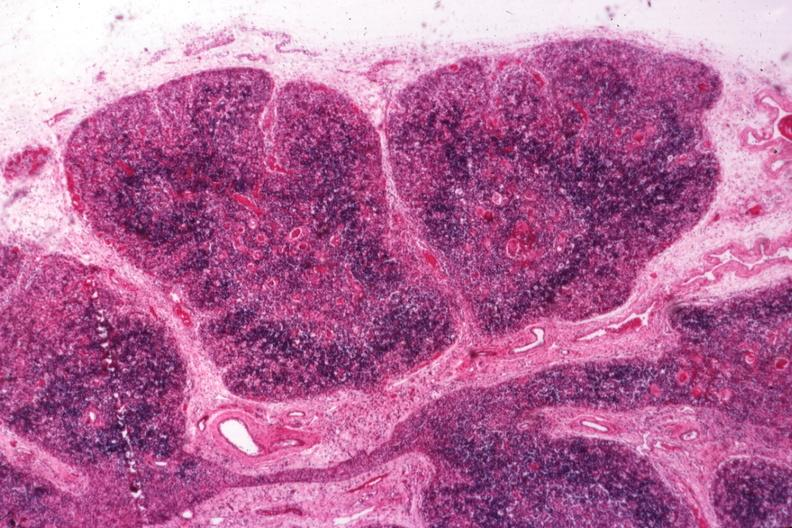how is typical atrophy associated with infection in?
Answer the question using a single word or phrase. Newborn 